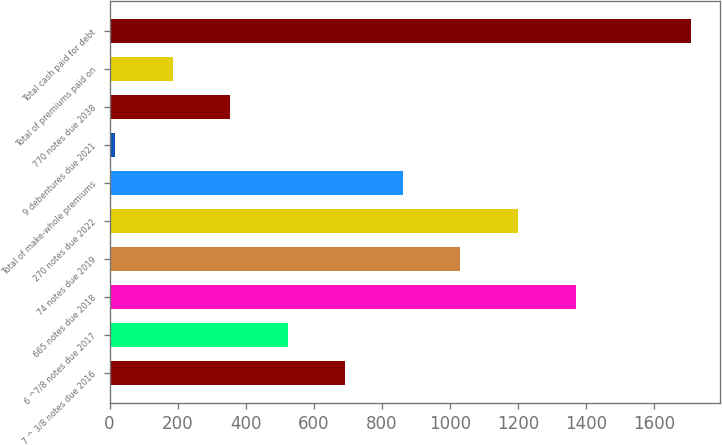<chart> <loc_0><loc_0><loc_500><loc_500><bar_chart><fcel>7 ^ 3/8 notes due 2016<fcel>6 ^7/8 notes due 2017<fcel>665 notes due 2018<fcel>74 notes due 2019<fcel>270 notes due 2022<fcel>Total of make-whole premiums<fcel>9 debentures due 2021<fcel>770 notes due 2038<fcel>Total of premiums paid on<fcel>Total cash paid for debt<nl><fcel>692.4<fcel>523.3<fcel>1368.8<fcel>1030.6<fcel>1199.7<fcel>861.5<fcel>16<fcel>354.2<fcel>185.1<fcel>1707<nl></chart> 